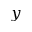<formula> <loc_0><loc_0><loc_500><loc_500>y</formula> 